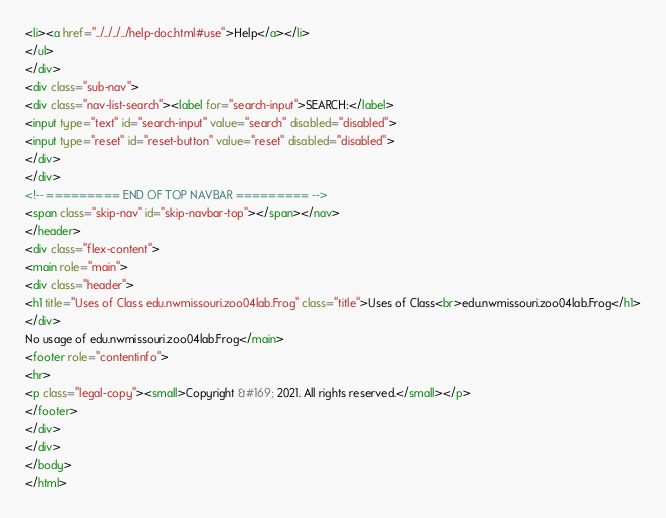<code> <loc_0><loc_0><loc_500><loc_500><_HTML_><li><a href="../../../../help-doc.html#use">Help</a></li>
</ul>
</div>
<div class="sub-nav">
<div class="nav-list-search"><label for="search-input">SEARCH:</label>
<input type="text" id="search-input" value="search" disabled="disabled">
<input type="reset" id="reset-button" value="reset" disabled="disabled">
</div>
</div>
<!-- ========= END OF TOP NAVBAR ========= -->
<span class="skip-nav" id="skip-navbar-top"></span></nav>
</header>
<div class="flex-content">
<main role="main">
<div class="header">
<h1 title="Uses of Class edu.nwmissouri.zoo04lab.Frog" class="title">Uses of Class<br>edu.nwmissouri.zoo04lab.Frog</h1>
</div>
No usage of edu.nwmissouri.zoo04lab.Frog</main>
<footer role="contentinfo">
<hr>
<p class="legal-copy"><small>Copyright &#169; 2021. All rights reserved.</small></p>
</footer>
</div>
</div>
</body>
</html>
</code> 